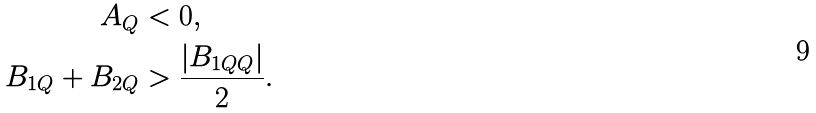<formula> <loc_0><loc_0><loc_500><loc_500>A _ { Q } & < 0 , \\ B _ { 1 Q } + B _ { 2 Q } & > \frac { | B _ { 1 Q Q } | } { 2 } .</formula> 